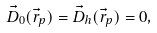<formula> <loc_0><loc_0><loc_500><loc_500>\vec { D } _ { 0 } ( \vec { r } _ { p } ) = \vec { D } _ { h } ( \vec { r } _ { p } ) = 0 ,</formula> 